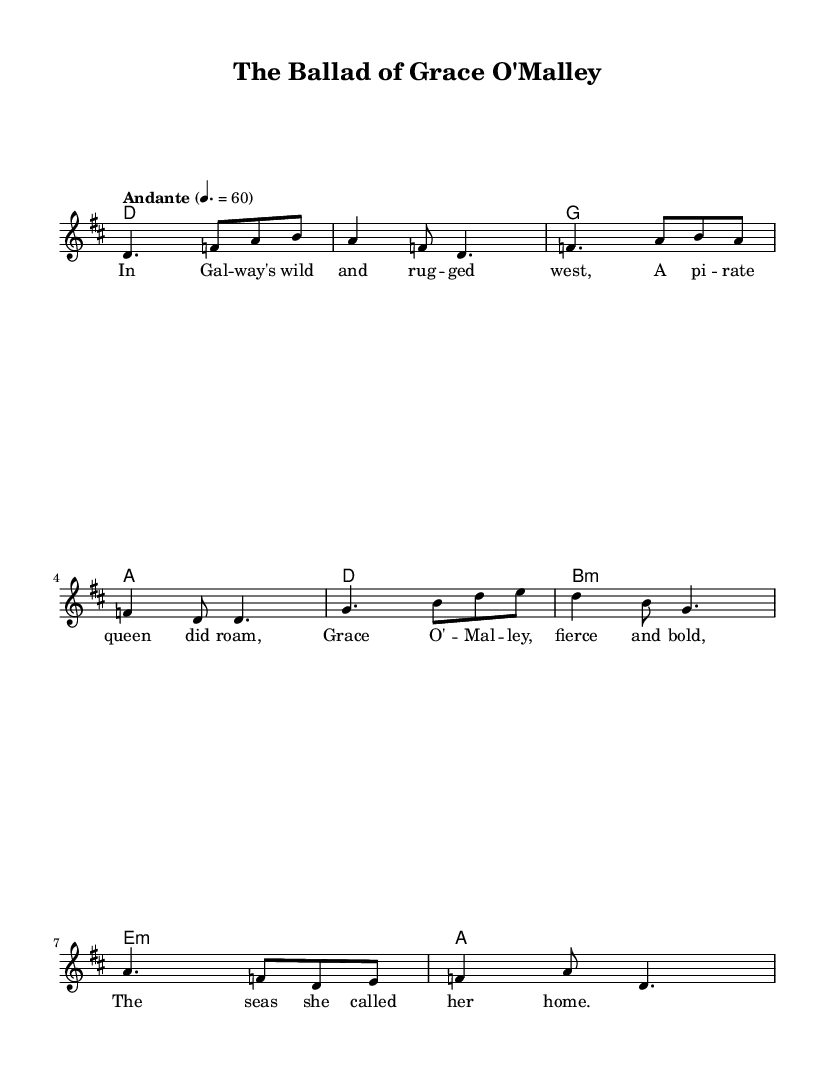What is the key signature of this music? The key signature is indicated at the beginning of the score and shows two sharps, which correspond to the D major scale.
Answer: D major What is the time signature of this music? The time signature, shown at the beginning of the score, is 6/8, indicating there are six eighth notes in each measure.
Answer: 6/8 What is the tempo marking for this piece? The tempo is specified as "Andante," meaning a moderately slow tempo, and it shows a speed of 60 beats per minute.
Answer: Andante What is the thematic subject of the lyrics? The lyrics reference a historical figure, Grace O'Malley, a pirate queen from Galway, emphasizing her strength and connection to the sea.
Answer: Grace O'Malley How many measures does the melody consist of? To determine this, one can count the individual segments separated by bars in the melody. There is a total of six measures shown in the score.
Answer: Six What are the first two chords in the harmony section? The first two chords in the harmony section are indicated as D and G, which can be identified by looking at the chord names listed above the staff.
Answer: D, G What cultural significance does this ballad hold? This ballad highlights the legend of a prominent female figure in Irish history, reflecting themes of strength and adventure in traditional Celtic folklore.
Answer: Irish folklore 